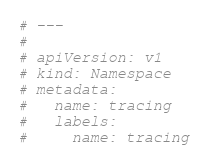Convert code to text. <code><loc_0><loc_0><loc_500><loc_500><_YAML_># ---
#
# apiVersion: v1
# kind: Namespace
# metadata:
#   name: tracing
#   labels:
#     name: tracing</code> 